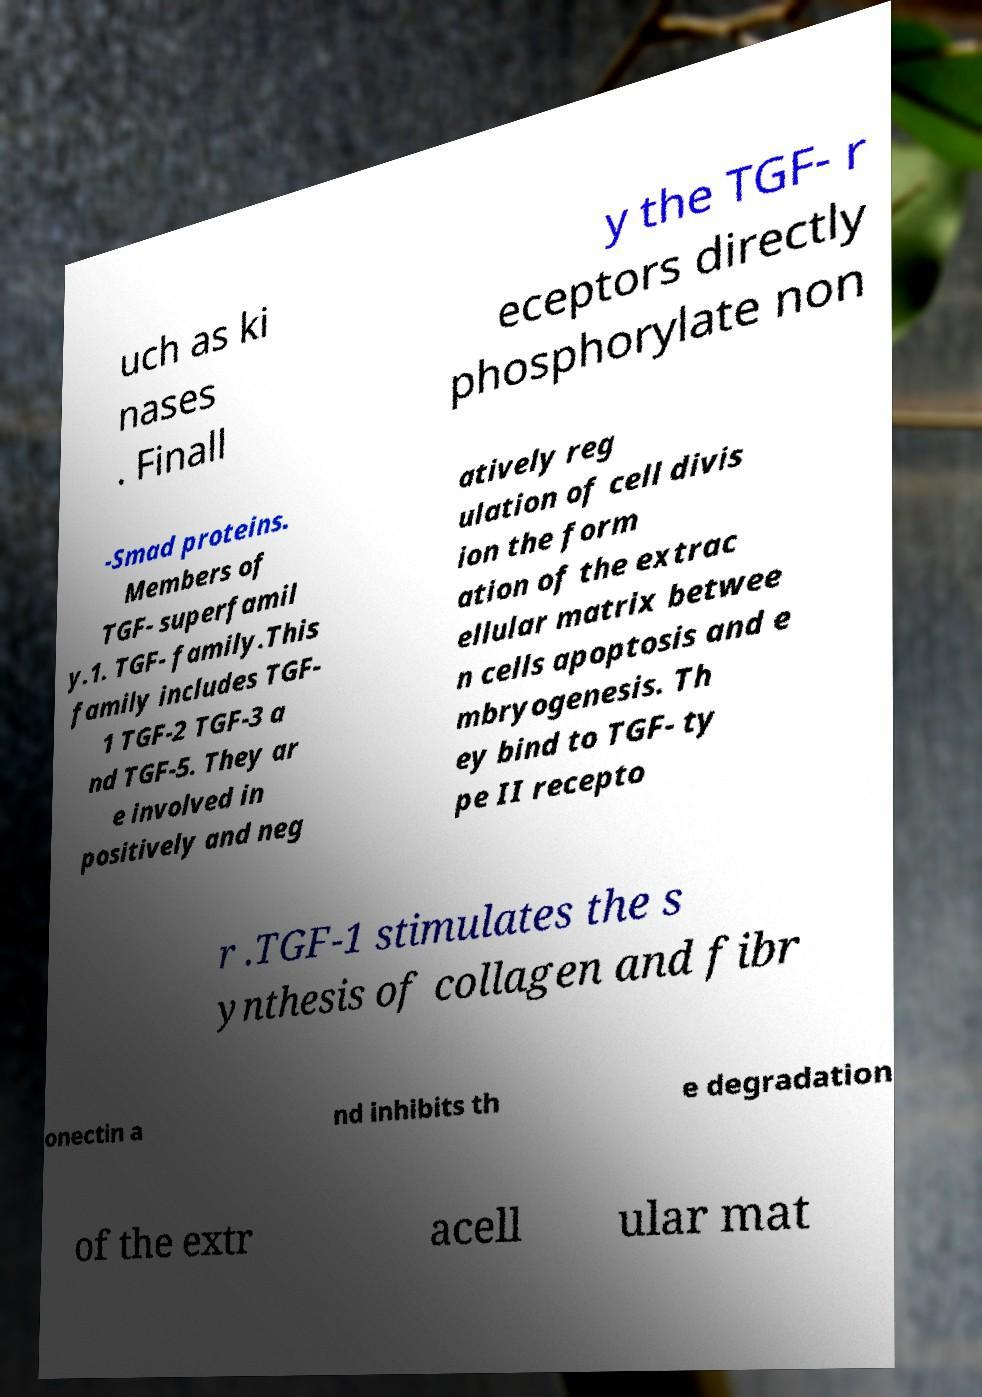I need the written content from this picture converted into text. Can you do that? uch as ki nases . Finall y the TGF- r eceptors directly phosphorylate non -Smad proteins. Members of TGF- superfamil y.1. TGF- family.This family includes TGF- 1 TGF-2 TGF-3 a nd TGF-5. They ar e involved in positively and neg atively reg ulation of cell divis ion the form ation of the extrac ellular matrix betwee n cells apoptosis and e mbryogenesis. Th ey bind to TGF- ty pe II recepto r .TGF-1 stimulates the s ynthesis of collagen and fibr onectin a nd inhibits th e degradation of the extr acell ular mat 